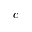Convert formula to latex. <formula><loc_0><loc_0><loc_500><loc_500>c</formula> 